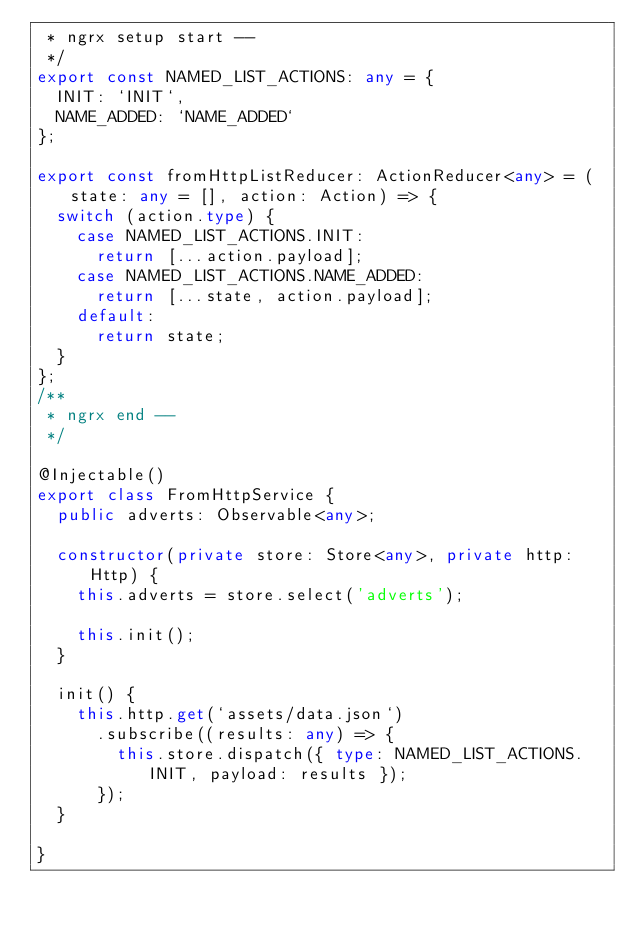<code> <loc_0><loc_0><loc_500><loc_500><_TypeScript_> * ngrx setup start --
 */
export const NAMED_LIST_ACTIONS: any = {
  INIT: `INIT`,
  NAME_ADDED: `NAME_ADDED`
};

export const fromHttpListReducer: ActionReducer<any> = (state: any = [], action: Action) => {
  switch (action.type) {
    case NAMED_LIST_ACTIONS.INIT:
      return [...action.payload];
    case NAMED_LIST_ACTIONS.NAME_ADDED:
      return [...state, action.payload];
    default:
      return state;
  }
};
/**
 * ngrx end --
 */

@Injectable()
export class FromHttpService {    
  public adverts: Observable<any>;

  constructor(private store: Store<any>, private http: Http) {
    this.adverts = store.select('adverts');

    this.init();
  }  

  init() {
    this.http.get(`assets/data.json`)
      .subscribe((results: any) => {
        this.store.dispatch({ type: NAMED_LIST_ACTIONS.INIT, payload: results });
      });
  }
 
}
</code> 